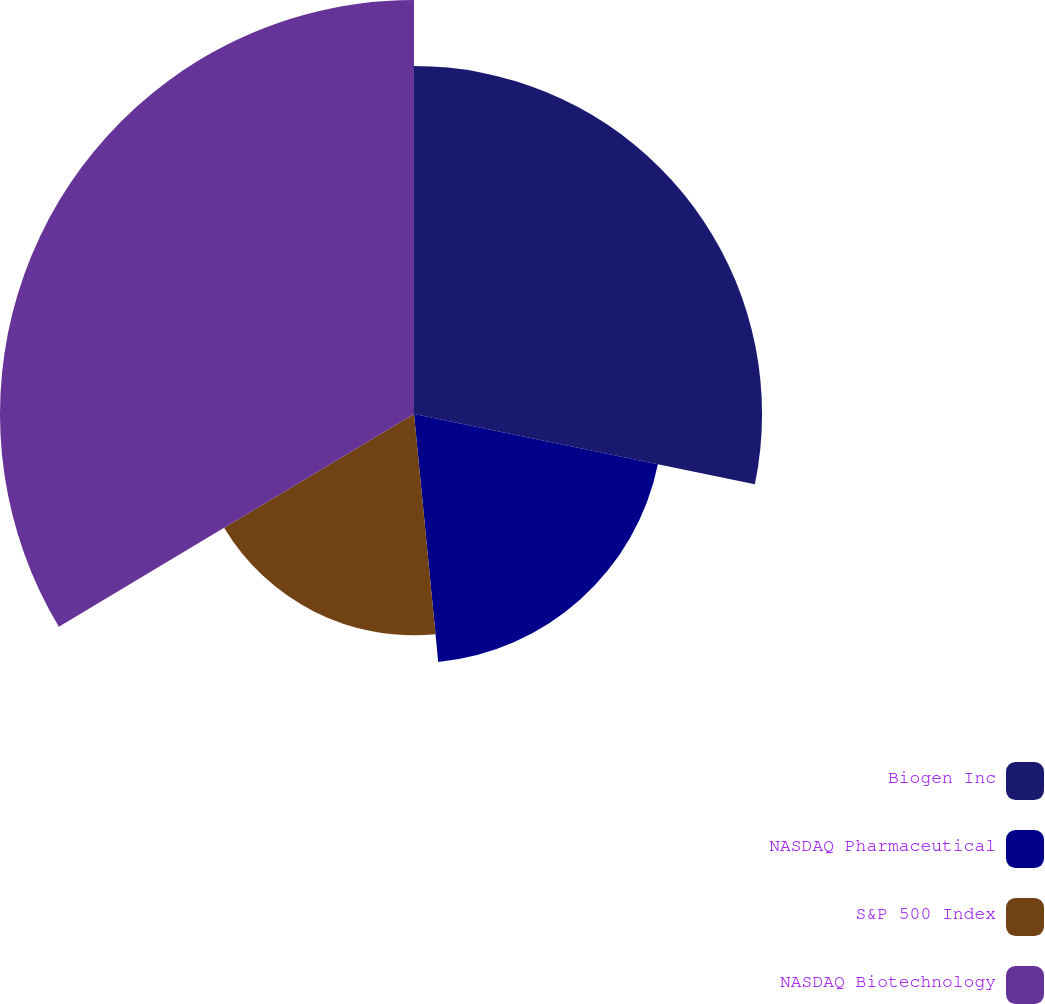<chart> <loc_0><loc_0><loc_500><loc_500><pie_chart><fcel>Biogen Inc<fcel>NASDAQ Pharmaceutical<fcel>S&P 500 Index<fcel>NASDAQ Biotechnology<nl><fcel>28.24%<fcel>20.21%<fcel>17.96%<fcel>33.59%<nl></chart> 